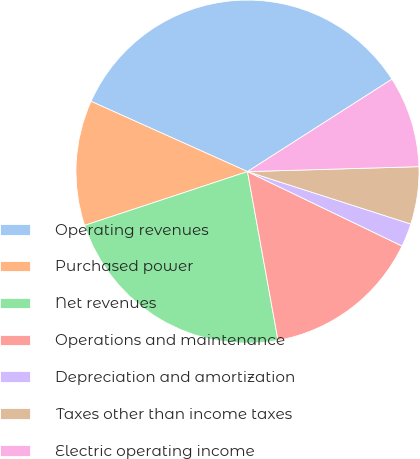Convert chart to OTSL. <chart><loc_0><loc_0><loc_500><loc_500><pie_chart><fcel>Operating revenues<fcel>Purchased power<fcel>Net revenues<fcel>Operations and maintenance<fcel>Depreciation and amortization<fcel>Taxes other than income taxes<fcel>Electric operating income<nl><fcel>34.22%<fcel>11.8%<fcel>22.77%<fcel>15.01%<fcel>2.2%<fcel>5.4%<fcel>8.6%<nl></chart> 